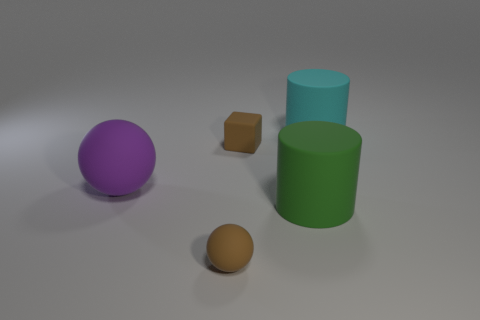Add 4 green cylinders. How many objects exist? 9 Subtract 1 brown cubes. How many objects are left? 4 Subtract all cubes. How many objects are left? 4 Subtract all tiny blue balls. Subtract all purple objects. How many objects are left? 4 Add 5 big cyan cylinders. How many big cyan cylinders are left? 6 Add 2 gray metallic spheres. How many gray metallic spheres exist? 2 